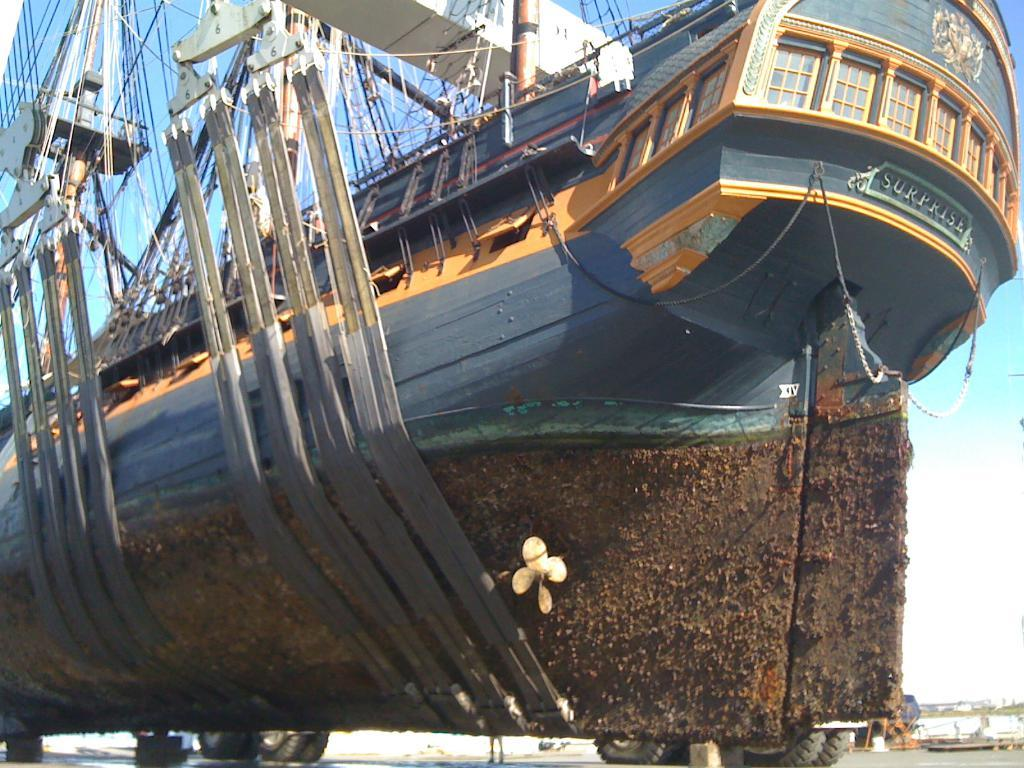What is the main subject of the image? There is a ship in the image. Where is the ship located? The ship is on the ground. What can be seen on top of the ship? There are metal rods and ropes on top of the ship. What is visible on the right side of the image? There are buildings on the right side of the image. What is visible at the top of the image? The sky is visible in the image. How many patients are waiting in the hospital depicted in the image? There is no hospital present in the image; it features a ship on the ground with metal rods and ropes on top, surrounded by buildings and the sky. What type of cracker is being used to navigate the ship in the image? There is no cracker present in the image, nor is there any indication of navigation. 